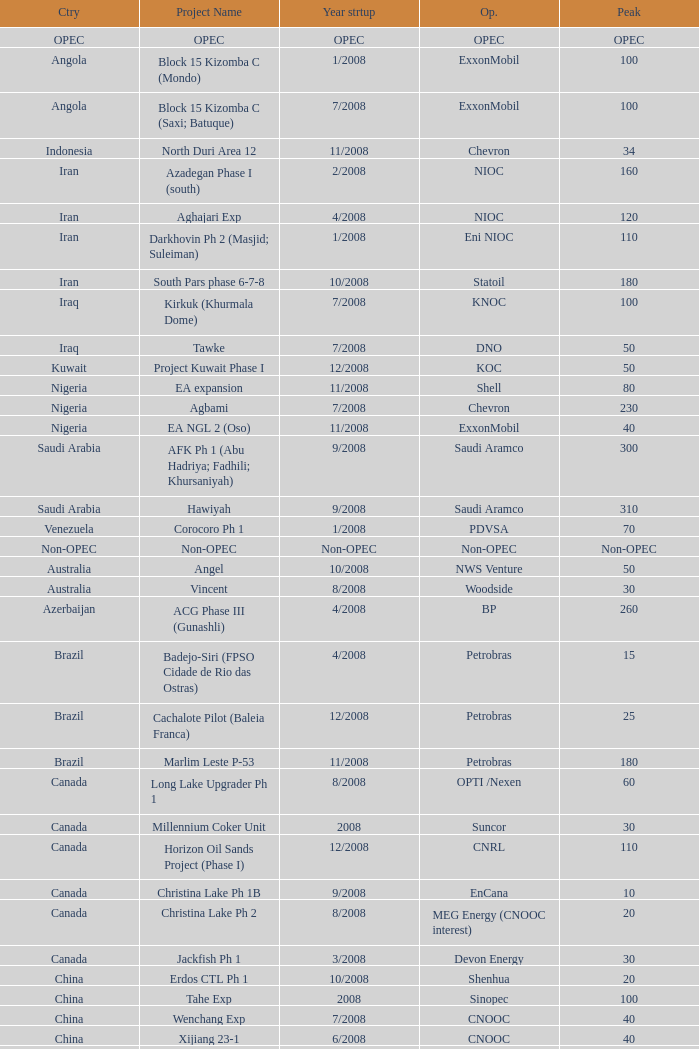What is the Project Name with a Country that is kazakhstan and a Peak that is 150? Dunga. Parse the table in full. {'header': ['Ctry', 'Project Name', 'Year strtup', 'Op.', 'Peak'], 'rows': [['OPEC', 'OPEC', 'OPEC', 'OPEC', 'OPEC'], ['Angola', 'Block 15 Kizomba C (Mondo)', '1/2008', 'ExxonMobil', '100'], ['Angola', 'Block 15 Kizomba C (Saxi; Batuque)', '7/2008', 'ExxonMobil', '100'], ['Indonesia', 'North Duri Area 12', '11/2008', 'Chevron', '34'], ['Iran', 'Azadegan Phase I (south)', '2/2008', 'NIOC', '160'], ['Iran', 'Aghajari Exp', '4/2008', 'NIOC', '120'], ['Iran', 'Darkhovin Ph 2 (Masjid; Suleiman)', '1/2008', 'Eni NIOC', '110'], ['Iran', 'South Pars phase 6-7-8', '10/2008', 'Statoil', '180'], ['Iraq', 'Kirkuk (Khurmala Dome)', '7/2008', 'KNOC', '100'], ['Iraq', 'Tawke', '7/2008', 'DNO', '50'], ['Kuwait', 'Project Kuwait Phase I', '12/2008', 'KOC', '50'], ['Nigeria', 'EA expansion', '11/2008', 'Shell', '80'], ['Nigeria', 'Agbami', '7/2008', 'Chevron', '230'], ['Nigeria', 'EA NGL 2 (Oso)', '11/2008', 'ExxonMobil', '40'], ['Saudi Arabia', 'AFK Ph 1 (Abu Hadriya; Fadhili; Khursaniyah)', '9/2008', 'Saudi Aramco', '300'], ['Saudi Arabia', 'Hawiyah', '9/2008', 'Saudi Aramco', '310'], ['Venezuela', 'Corocoro Ph 1', '1/2008', 'PDVSA', '70'], ['Non-OPEC', 'Non-OPEC', 'Non-OPEC', 'Non-OPEC', 'Non-OPEC'], ['Australia', 'Angel', '10/2008', 'NWS Venture', '50'], ['Australia', 'Vincent', '8/2008', 'Woodside', '30'], ['Azerbaijan', 'ACG Phase III (Gunashli)', '4/2008', 'BP', '260'], ['Brazil', 'Badejo-Siri (FPSO Cidade de Rio das Ostras)', '4/2008', 'Petrobras', '15'], ['Brazil', 'Cachalote Pilot (Baleia Franca)', '12/2008', 'Petrobras', '25'], ['Brazil', 'Marlim Leste P-53', '11/2008', 'Petrobras', '180'], ['Canada', 'Long Lake Upgrader Ph 1', '8/2008', 'OPTI /Nexen', '60'], ['Canada', 'Millennium Coker Unit', '2008', 'Suncor', '30'], ['Canada', 'Horizon Oil Sands Project (Phase I)', '12/2008', 'CNRL', '110'], ['Canada', 'Christina Lake Ph 1B', '9/2008', 'EnCana', '10'], ['Canada', 'Christina Lake Ph 2', '8/2008', 'MEG Energy (CNOOC interest)', '20'], ['Canada', 'Jackfish Ph 1', '3/2008', 'Devon Energy', '30'], ['China', 'Erdos CTL Ph 1', '10/2008', 'Shenhua', '20'], ['China', 'Tahe Exp', '2008', 'Sinopec', '100'], ['China', 'Wenchang Exp', '7/2008', 'CNOOC', '40'], ['China', 'Xijiang 23-1', '6/2008', 'CNOOC', '40'], ['Congo', 'Moho Bilondo', '4/2008', 'Total', '90'], ['Egypt', 'Saqqara', '3/2008', 'BP', '40'], ['India', 'MA field (KG-D6)', '9/2008', 'Reliance', '40'], ['Kazakhstan', 'Dunga', '3/2008', 'Maersk', '150'], ['Kazakhstan', 'Komsomolskoe', '5/2008', 'Petrom', '10'], ['Mexico', '( Chicontepec ) Exp 1', '2008', 'PEMEX', '200'], ['Mexico', 'Antonio J Bermudez Exp', '5/2008', 'PEMEX', '20'], ['Mexico', 'Bellota Chinchorro Exp', '5/2008', 'PEMEX', '20'], ['Mexico', 'Ixtal Manik', '2008', 'PEMEX', '55'], ['Mexico', 'Jujo Tecominoacan Exp', '2008', 'PEMEX', '15'], ['Norway', 'Alvheim; Volund; Vilje', '6/2008', 'Marathon', '100'], ['Norway', 'Volve', '2/2008', 'StatoilHydro', '35'], ['Oman', 'Mukhaizna EOR Ph 1', '2008', 'Occidental', '40'], ['Philippines', 'Galoc', '10/2008', 'GPC', '15'], ['Russia', 'Talakan Ph 1', '10/2008', 'Surgutneftegaz', '60'], ['Russia', 'Verkhnechonsk Ph 1 (early oil)', '10/2008', 'TNK-BP Rosneft', '20'], ['Russia', 'Yuzhno-Khylchuyuskoye "YK" Ph 1', '8/2008', 'Lukoil ConocoPhillips', '75'], ['Thailand', 'Bualuang', '8/2008', 'Salamander', '10'], ['UK', 'Britannia Satellites (Callanish; Brodgar)', '7/2008', 'Conoco Phillips', '25'], ['USA', 'Blind Faith', '11/2008', 'Chevron', '45'], ['USA', 'Neptune', '7/2008', 'BHP Billiton', '25'], ['USA', 'Oooguruk', '6/2008', 'Pioneer', '15'], ['USA', 'Qannik', '7/2008', 'ConocoPhillips', '4'], ['USA', 'Thunder Horse', '6/2008', 'BP', '210'], ['USA', 'Ursa Princess Exp', '1/2008', 'Shell', '30'], ['Vietnam', 'Ca Ngu Vang (Golden Tuna)', '7/2008', 'HVJOC', '15'], ['Vietnam', 'Su Tu Vang', '10/2008', 'Cuu Long Joint', '40'], ['Vietnam', 'Song Doc', '12/2008', 'Talisman', '10']]} 